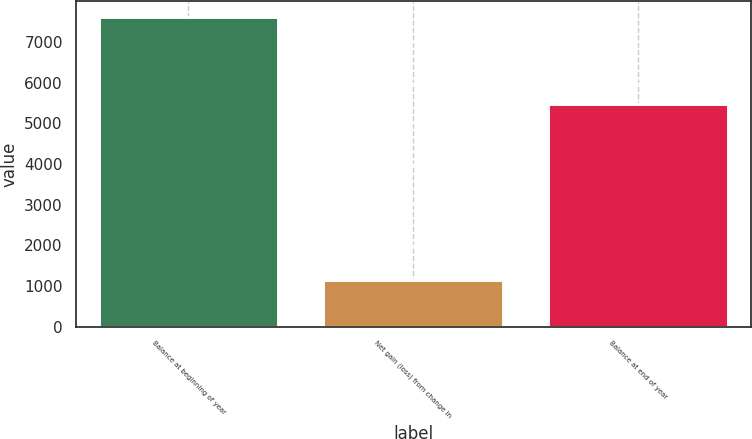<chart> <loc_0><loc_0><loc_500><loc_500><bar_chart><fcel>Balance at beginning of year<fcel>Net gain (loss) from change in<fcel>Balance at end of year<nl><fcel>7618<fcel>1144<fcel>5484<nl></chart> 